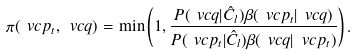Convert formula to latex. <formula><loc_0><loc_0><loc_500><loc_500>\pi ( \ v c { p } _ { t } , \ v c { q } ) = \min \left ( 1 , \frac { P ( \ v c { q } | \hat { C } _ { l } ) \beta ( \ v c { p } _ { t } | \ v c { q } ) } { P ( \ v c { p } _ { t } | \hat { C } _ { l } ) \beta ( \ v c { q } | \ v c { p } _ { t } ) } \right ) .</formula> 